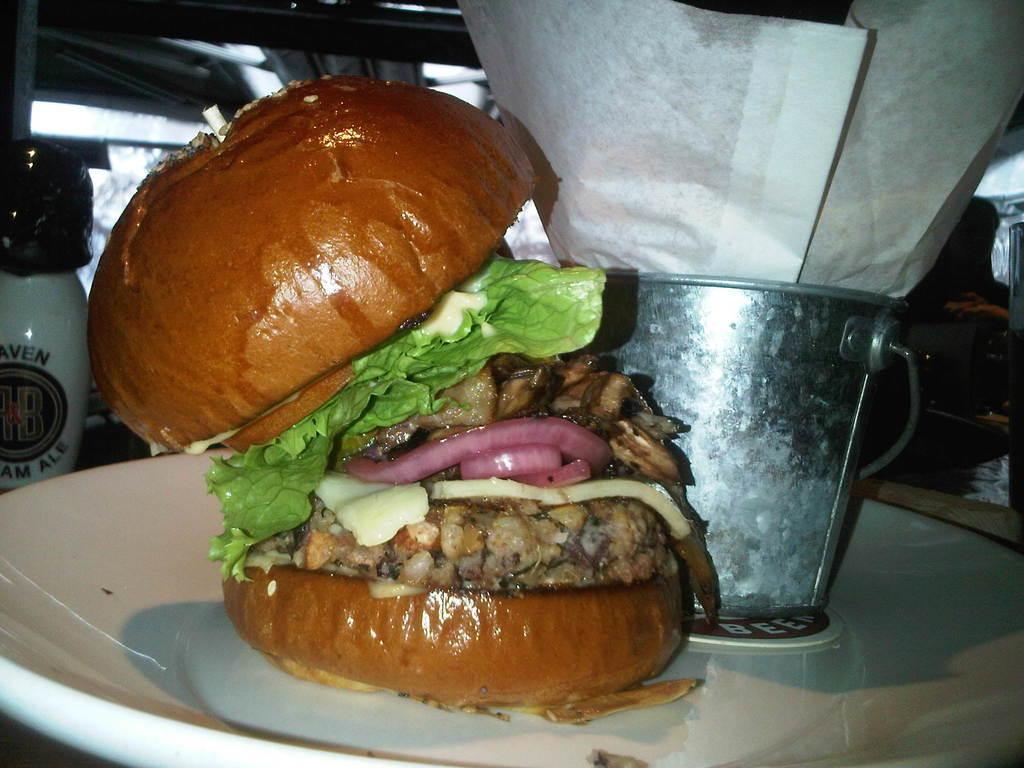Can you describe this image briefly? In this image, I can see a mini bucket with a paper and a burger are placed on a plate. On the left side of the image, there is a small bottle. In the background, I can see few objects. 